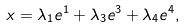Convert formula to latex. <formula><loc_0><loc_0><loc_500><loc_500>x = \lambda _ { 1 } e ^ { 1 } + \lambda _ { 3 } e ^ { 3 } + \lambda _ { 4 } e ^ { 4 } ,</formula> 